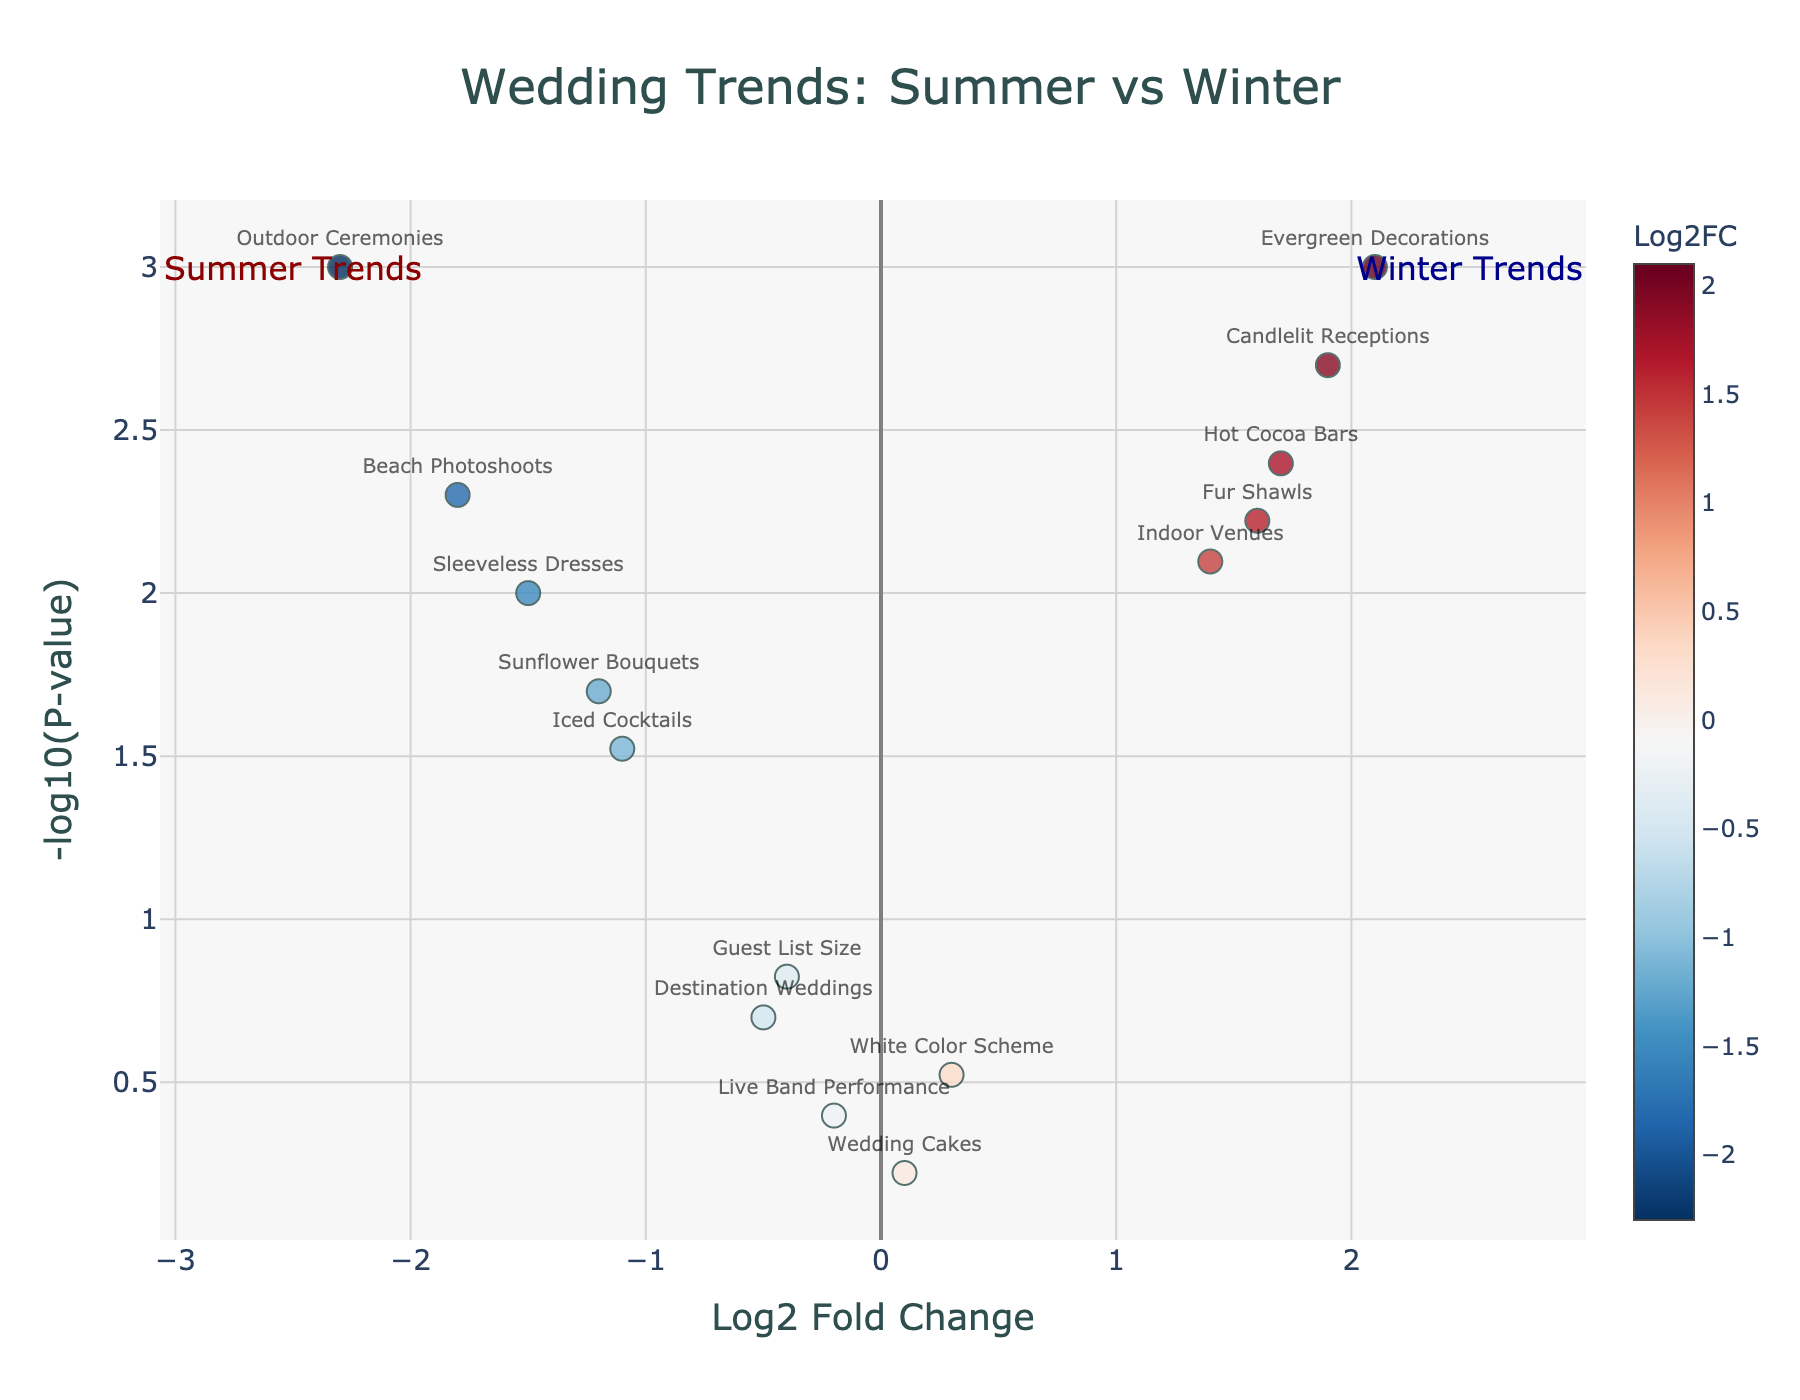What is the title of the plot? The title of the plot is located at the top center of the figure. The title reads "Wedding Trends: Summer vs Winter".
Answer: "Wedding Trends: Summer vs Winter" Which trend has the highest -log10(P-value)? To find the trend with the highest -log10(P-value), look for the point that appears highest on the Y-axis. The highest point corresponds to "Outdoor Ceremonies" with a -log10(P-value) greater than 3.
Answer: "Outdoor Ceremonies" What is the Log2 Fold Change of "Hot Cocoa Bars"? Find "Hot Cocoa Bars" on the plot and refer to its position on the X-axis. "Hot Cocoa Bars" shows a Log2FC of 1.7.
Answer: 1.7 How many winter trends are significantly different compared to summer trends? Winter trends are those with positive Log2FC and a high -log10(P-value). We identify significant trends as those with a -log10(P-value) greater than 2. There are 5 of such winter trends: Indoor Venues, Fur Shawls, Hot Cocoa Bars, Candlelit Receptions, and Evergreen Decorations.
Answer: 5 Which trend has the lowest absolute Log2FC but is still significant? Check all points with -log10(P-value) greater than 2 (significant trends). Among these, the trend with the lowest absolute Log2FC (closest to zero) is "Iced Cocktails" with a Log2FC of -1.1.
Answer: "Iced Cocktails" Compare the Log2 Fold Change values between "Candlelit Receptions" and "Evergreen Decorations". Which one is higher? Find both "Candlelit Receptions" and "Evergreen Decorations" on the plot. Compare their X-axis positions. "Evergreen Decorations" has a Log2FC of 2.1, whereas "Candlelit Receptions" has a Log2FC of 1.9. Therefore, Evergreen Decorations is higher.
Answer: "Evergreen Decorations" What's the general trend of "Beach Photoshoots" in winter compared to summer? Locate the point for "Beach Photoshoots." Its Log2FC is -1.8, indicating a significant decrease in winter compared to summer. This is further confirmed by its position on the left side of the plot.
Answer: Decrease How many trends have a P-value above 0.05? On a volcano plot, trends with a P-value above 0.05 will have a -log10(P-value) less than approximately 1.3 (since -log10(0.05) ≈ 1.3). By inspecting these, we find that "Guest List Size," "Destination Weddings," "White Color Scheme," "Live Band Performance," and "Wedding Cakes" fit this criterion. That makes it 5 trends.
Answer: 5 Is it more common to see indoor venues in winter weddings based on the plot? Look at the Log2FC value for "Indoor Venues". It has a positive Log2FC of 1.4, indicating that it is more common in winter weddings.
Answer: Yes Which trend has a higher significance, "Sunflower Bouquets" or "Hot Cocoa Bars"? Compare the -log10(P-value) for "Sunflower Bouquets" and "Hot Cocoa Bars." "Hot Cocoa Bars" has a higher position on the Y-axis (-log10(P-value)=2.4) compared to "Sunflower Bouquets" (-log10(P-value)=1.7), hence it has higher significance.
Answer: "Hot Cocoa Bars" 